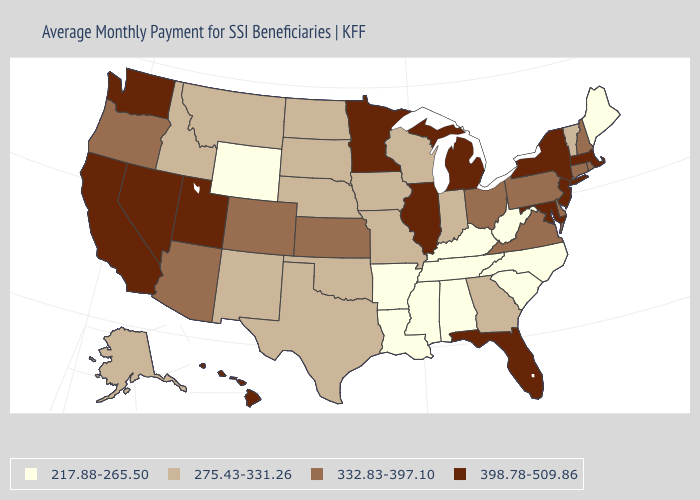Does Illinois have a higher value than Oklahoma?
Concise answer only. Yes. What is the highest value in the USA?
Be succinct. 398.78-509.86. What is the value of Arkansas?
Give a very brief answer. 217.88-265.50. Among the states that border Oklahoma , does Colorado have the highest value?
Give a very brief answer. Yes. Among the states that border New Hampshire , which have the highest value?
Quick response, please. Massachusetts. Does Wyoming have the highest value in the West?
Concise answer only. No. What is the lowest value in states that border South Carolina?
Answer briefly. 217.88-265.50. Among the states that border Pennsylvania , which have the highest value?
Write a very short answer. Maryland, New Jersey, New York. What is the value of Alaska?
Concise answer only. 275.43-331.26. Which states have the lowest value in the USA?
Give a very brief answer. Alabama, Arkansas, Kentucky, Louisiana, Maine, Mississippi, North Carolina, South Carolina, Tennessee, West Virginia, Wyoming. What is the lowest value in the USA?
Short answer required. 217.88-265.50. Does the first symbol in the legend represent the smallest category?
Quick response, please. Yes. What is the value of Maryland?
Write a very short answer. 398.78-509.86. Does Wyoming have the lowest value in the USA?
Give a very brief answer. Yes. 